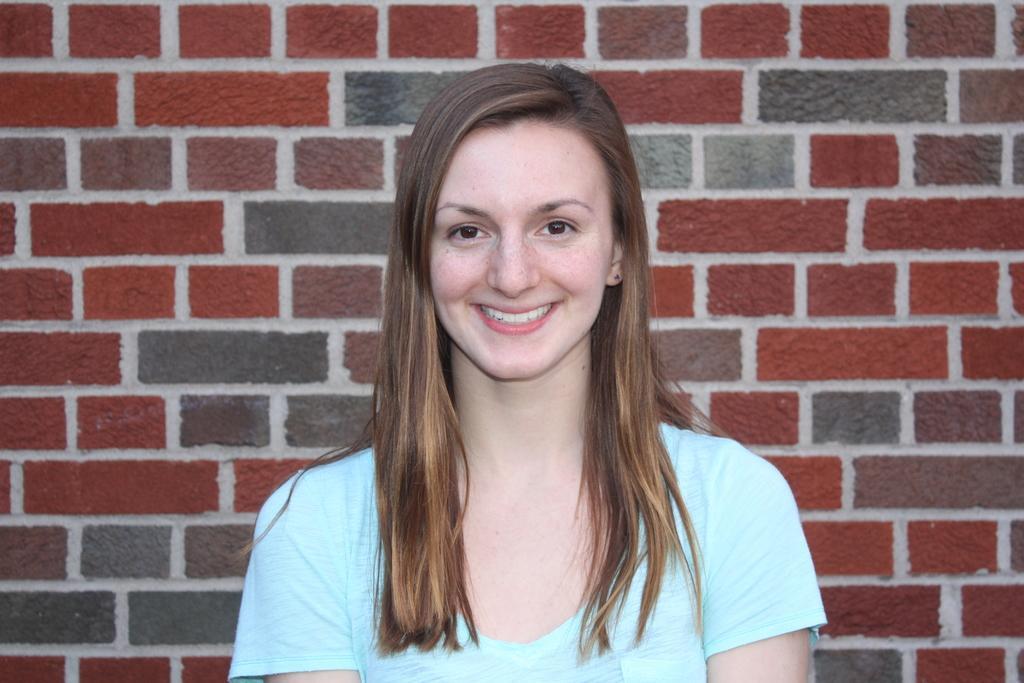Describe this image in one or two sentences. In this image we can see a woman smiling and in the background, we can see the wall. 